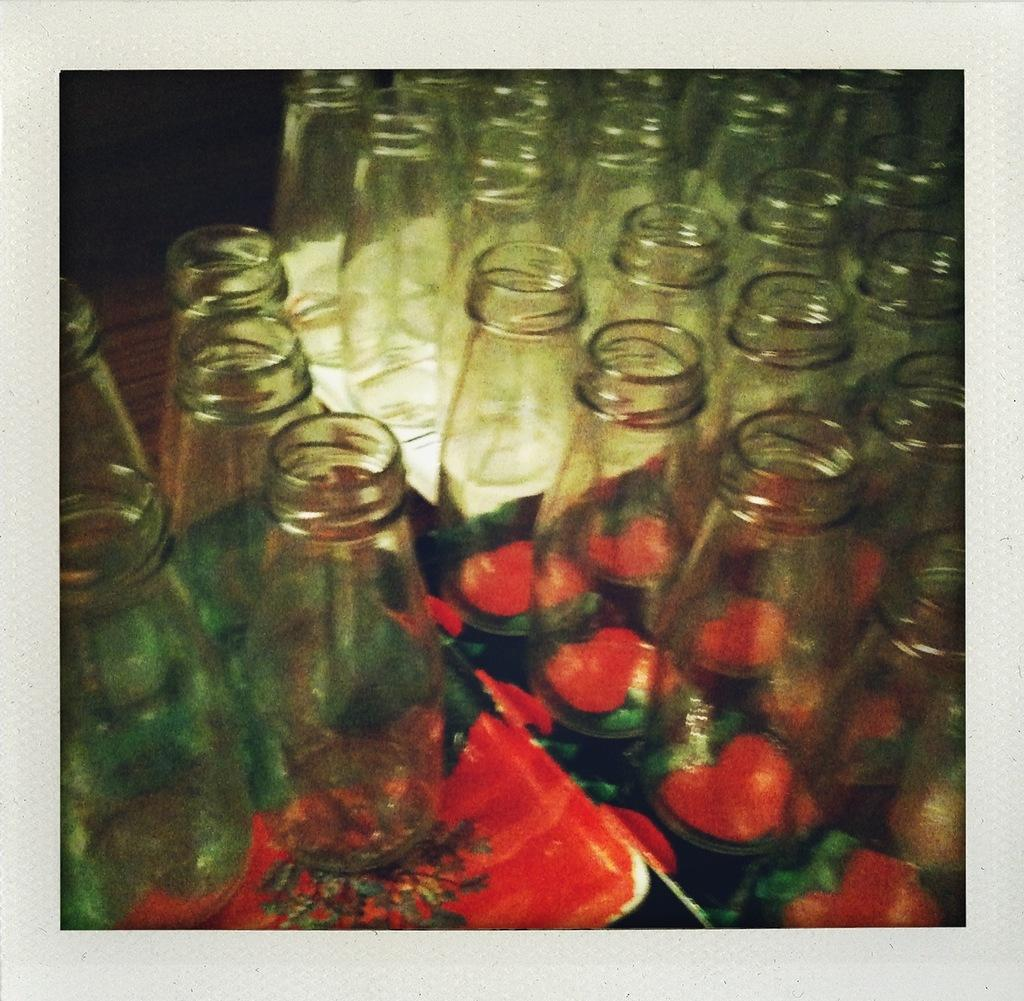What objects are located on the left side of the image? There are glass bottles on the left side of the image. How are the glass bottles positioned in the image? The glass bottles are placed on a plate. What is in the middle of the image? There is a mirror in the middle of the image. What can be seen on the right side of the image? The reflection of the glass bottles is visible on the right side of the image. What type of laborer can be seen working in the image? There is no laborer present in the image; it features glass bottles, a plate, a mirror, and their reflections. 